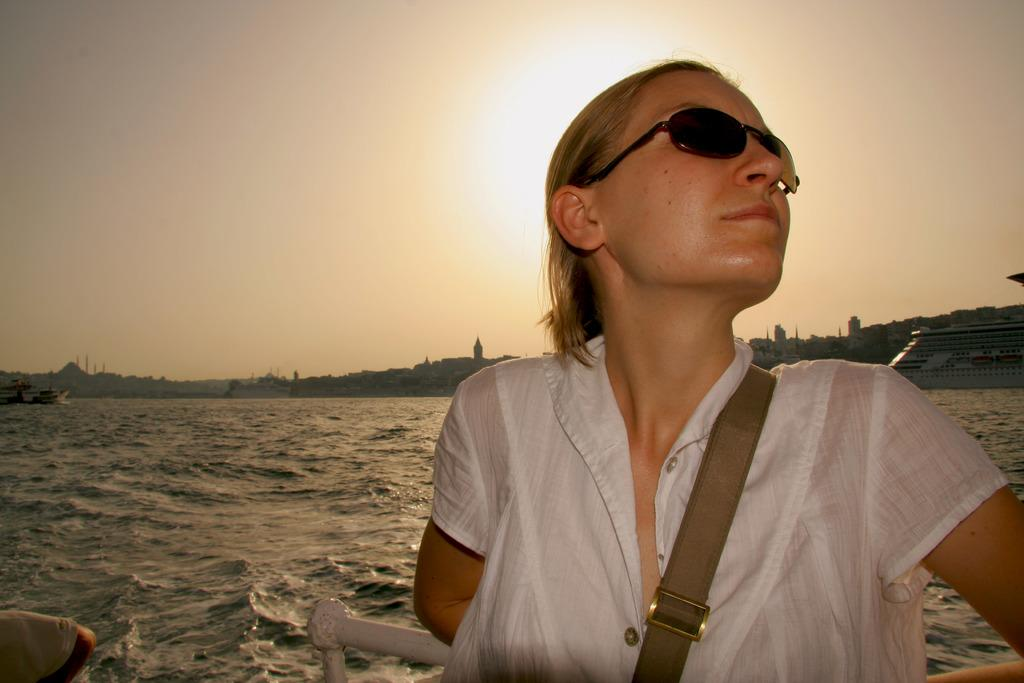Who is the main subject in the image? There is a woman in the center of the image. What is the woman wearing in the image? The woman is wearing spectacles. What can be seen in the background of the image? There is water, buildings, a ship, and the sky visible in the background of the image. What type of pet can be seen in the image? There is no pet visible in the image. How many doors are present in the scene? The term "scene" is not mentioned in the facts, and there is no mention of a door in the image. 